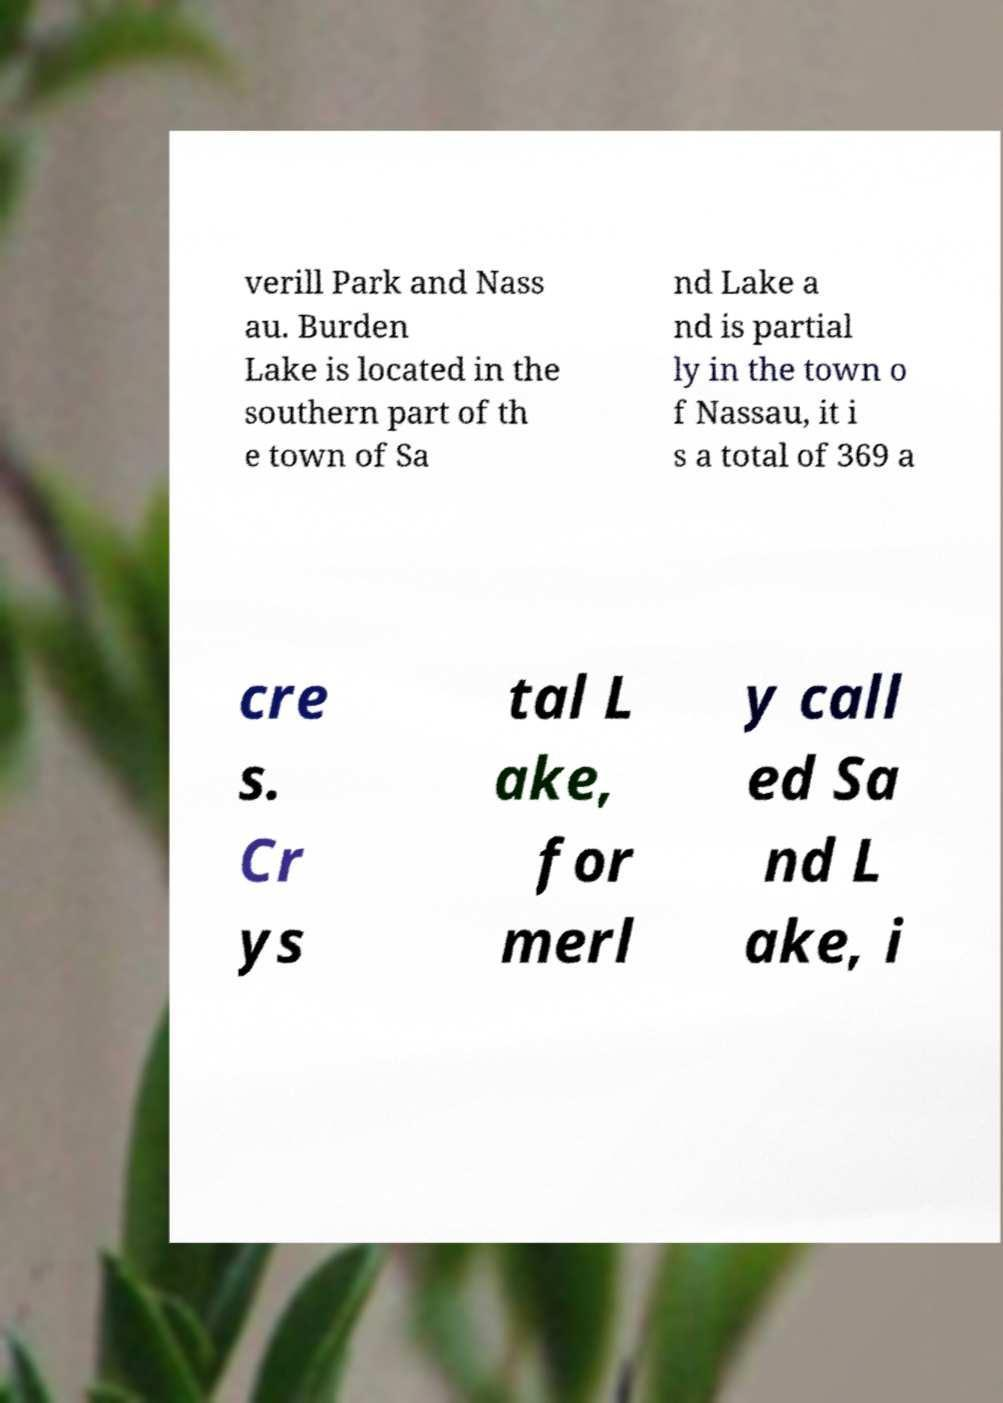For documentation purposes, I need the text within this image transcribed. Could you provide that? verill Park and Nass au. Burden Lake is located in the southern part of th e town of Sa nd Lake a nd is partial ly in the town o f Nassau, it i s a total of 369 a cre s. Cr ys tal L ake, for merl y call ed Sa nd L ake, i 